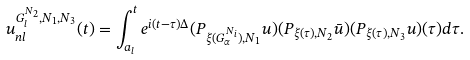Convert formula to latex. <formula><loc_0><loc_0><loc_500><loc_500>u _ { n l } ^ { G _ { l } ^ { N _ { 2 } } , N _ { 1 } , N _ { 3 } } ( t ) = \int _ { a _ { l } } ^ { t } e ^ { i ( t - \tau ) \Delta } ( P _ { \xi ( G _ { \alpha } ^ { N _ { i } } ) , N _ { 1 } } u ) ( P _ { \xi ( \tau ) , N _ { 2 } } \bar { u } ) ( P _ { \xi ( \tau ) , N _ { 3 } } u ) ( \tau ) d \tau .</formula> 